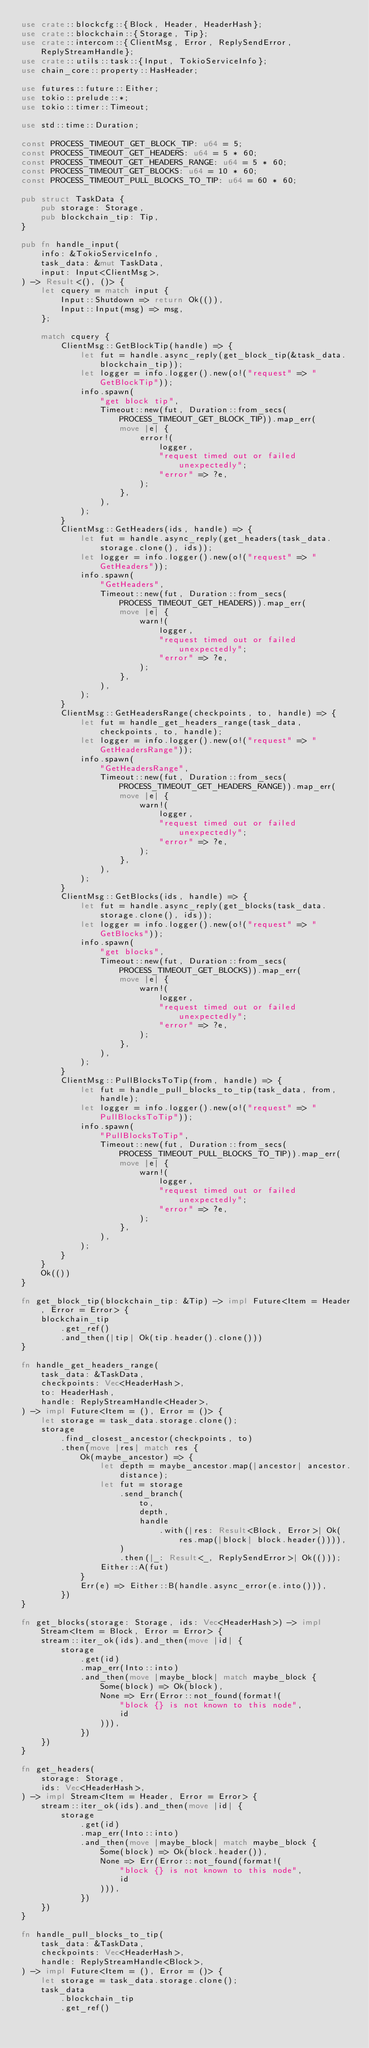<code> <loc_0><loc_0><loc_500><loc_500><_Rust_>use crate::blockcfg::{Block, Header, HeaderHash};
use crate::blockchain::{Storage, Tip};
use crate::intercom::{ClientMsg, Error, ReplySendError, ReplyStreamHandle};
use crate::utils::task::{Input, TokioServiceInfo};
use chain_core::property::HasHeader;

use futures::future::Either;
use tokio::prelude::*;
use tokio::timer::Timeout;

use std::time::Duration;

const PROCESS_TIMEOUT_GET_BLOCK_TIP: u64 = 5;
const PROCESS_TIMEOUT_GET_HEADERS: u64 = 5 * 60;
const PROCESS_TIMEOUT_GET_HEADERS_RANGE: u64 = 5 * 60;
const PROCESS_TIMEOUT_GET_BLOCKS: u64 = 10 * 60;
const PROCESS_TIMEOUT_PULL_BLOCKS_TO_TIP: u64 = 60 * 60;

pub struct TaskData {
    pub storage: Storage,
    pub blockchain_tip: Tip,
}

pub fn handle_input(
    info: &TokioServiceInfo,
    task_data: &mut TaskData,
    input: Input<ClientMsg>,
) -> Result<(), ()> {
    let cquery = match input {
        Input::Shutdown => return Ok(()),
        Input::Input(msg) => msg,
    };

    match cquery {
        ClientMsg::GetBlockTip(handle) => {
            let fut = handle.async_reply(get_block_tip(&task_data.blockchain_tip));
            let logger = info.logger().new(o!("request" => "GetBlockTip"));
            info.spawn(
                "get block tip",
                Timeout::new(fut, Duration::from_secs(PROCESS_TIMEOUT_GET_BLOCK_TIP)).map_err(
                    move |e| {
                        error!(
                            logger,
                            "request timed out or failed unexpectedly";
                            "error" => ?e,
                        );
                    },
                ),
            );
        }
        ClientMsg::GetHeaders(ids, handle) => {
            let fut = handle.async_reply(get_headers(task_data.storage.clone(), ids));
            let logger = info.logger().new(o!("request" => "GetHeaders"));
            info.spawn(
                "GetHeaders",
                Timeout::new(fut, Duration::from_secs(PROCESS_TIMEOUT_GET_HEADERS)).map_err(
                    move |e| {
                        warn!(
                            logger,
                            "request timed out or failed unexpectedly";
                            "error" => ?e,
                        );
                    },
                ),
            );
        }
        ClientMsg::GetHeadersRange(checkpoints, to, handle) => {
            let fut = handle_get_headers_range(task_data, checkpoints, to, handle);
            let logger = info.logger().new(o!("request" => "GetHeadersRange"));
            info.spawn(
                "GetHeadersRange",
                Timeout::new(fut, Duration::from_secs(PROCESS_TIMEOUT_GET_HEADERS_RANGE)).map_err(
                    move |e| {
                        warn!(
                            logger,
                            "request timed out or failed unexpectedly";
                            "error" => ?e,
                        );
                    },
                ),
            );
        }
        ClientMsg::GetBlocks(ids, handle) => {
            let fut = handle.async_reply(get_blocks(task_data.storage.clone(), ids));
            let logger = info.logger().new(o!("request" => "GetBlocks"));
            info.spawn(
                "get blocks",
                Timeout::new(fut, Duration::from_secs(PROCESS_TIMEOUT_GET_BLOCKS)).map_err(
                    move |e| {
                        warn!(
                            logger,
                            "request timed out or failed unexpectedly";
                            "error" => ?e,
                        );
                    },
                ),
            );
        }
        ClientMsg::PullBlocksToTip(from, handle) => {
            let fut = handle_pull_blocks_to_tip(task_data, from, handle);
            let logger = info.logger().new(o!("request" => "PullBlocksToTip"));
            info.spawn(
                "PullBlocksToTip",
                Timeout::new(fut, Duration::from_secs(PROCESS_TIMEOUT_PULL_BLOCKS_TO_TIP)).map_err(
                    move |e| {
                        warn!(
                            logger,
                            "request timed out or failed unexpectedly";
                            "error" => ?e,
                        );
                    },
                ),
            );
        }
    }
    Ok(())
}

fn get_block_tip(blockchain_tip: &Tip) -> impl Future<Item = Header, Error = Error> {
    blockchain_tip
        .get_ref()
        .and_then(|tip| Ok(tip.header().clone()))
}

fn handle_get_headers_range(
    task_data: &TaskData,
    checkpoints: Vec<HeaderHash>,
    to: HeaderHash,
    handle: ReplyStreamHandle<Header>,
) -> impl Future<Item = (), Error = ()> {
    let storage = task_data.storage.clone();
    storage
        .find_closest_ancestor(checkpoints, to)
        .then(move |res| match res {
            Ok(maybe_ancestor) => {
                let depth = maybe_ancestor.map(|ancestor| ancestor.distance);
                let fut = storage
                    .send_branch(
                        to,
                        depth,
                        handle
                            .with(|res: Result<Block, Error>| Ok(res.map(|block| block.header()))),
                    )
                    .then(|_: Result<_, ReplySendError>| Ok(()));
                Either::A(fut)
            }
            Err(e) => Either::B(handle.async_error(e.into())),
        })
}

fn get_blocks(storage: Storage, ids: Vec<HeaderHash>) -> impl Stream<Item = Block, Error = Error> {
    stream::iter_ok(ids).and_then(move |id| {
        storage
            .get(id)
            .map_err(Into::into)
            .and_then(move |maybe_block| match maybe_block {
                Some(block) => Ok(block),
                None => Err(Error::not_found(format!(
                    "block {} is not known to this node",
                    id
                ))),
            })
    })
}

fn get_headers(
    storage: Storage,
    ids: Vec<HeaderHash>,
) -> impl Stream<Item = Header, Error = Error> {
    stream::iter_ok(ids).and_then(move |id| {
        storage
            .get(id)
            .map_err(Into::into)
            .and_then(move |maybe_block| match maybe_block {
                Some(block) => Ok(block.header()),
                None => Err(Error::not_found(format!(
                    "block {} is not known to this node",
                    id
                ))),
            })
    })
}

fn handle_pull_blocks_to_tip(
    task_data: &TaskData,
    checkpoints: Vec<HeaderHash>,
    handle: ReplyStreamHandle<Block>,
) -> impl Future<Item = (), Error = ()> {
    let storage = task_data.storage.clone();
    task_data
        .blockchain_tip
        .get_ref()</code> 